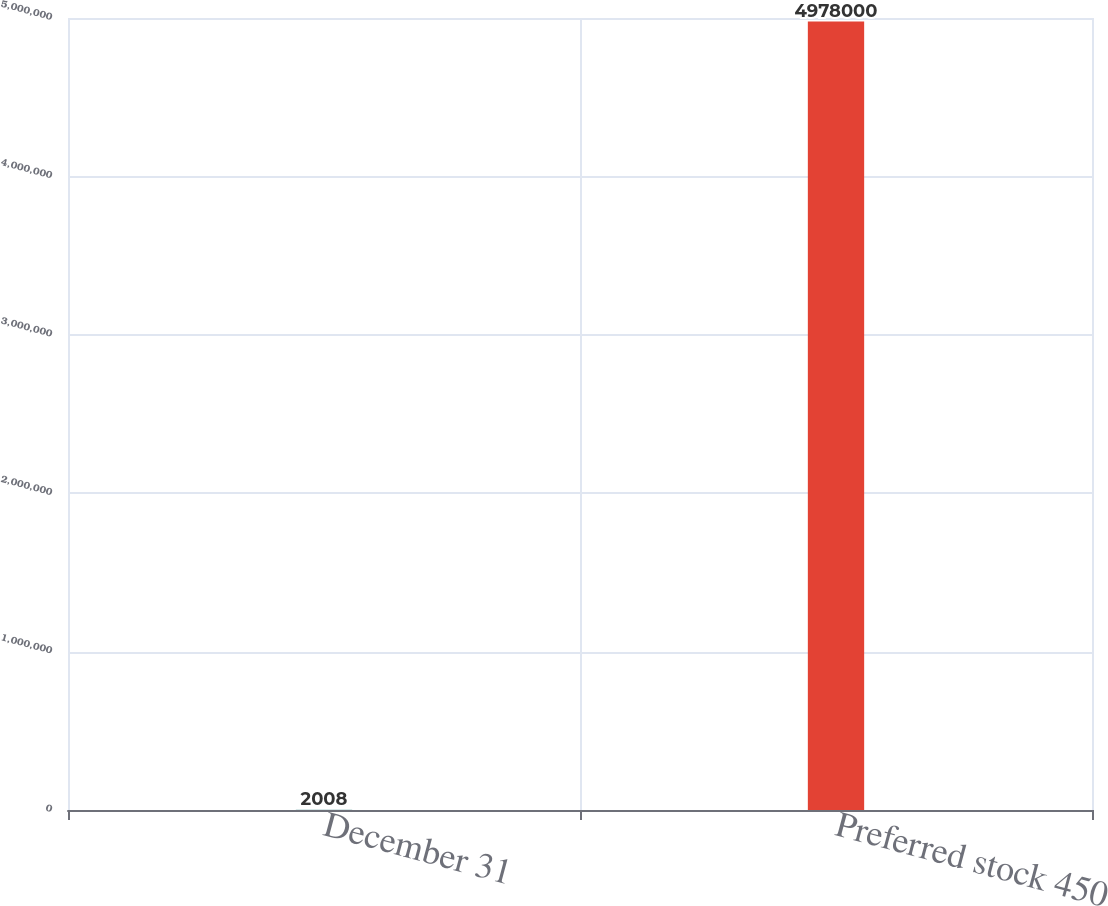Convert chart to OTSL. <chart><loc_0><loc_0><loc_500><loc_500><bar_chart><fcel>December 31<fcel>Preferred stock 450<nl><fcel>2008<fcel>4.978e+06<nl></chart> 